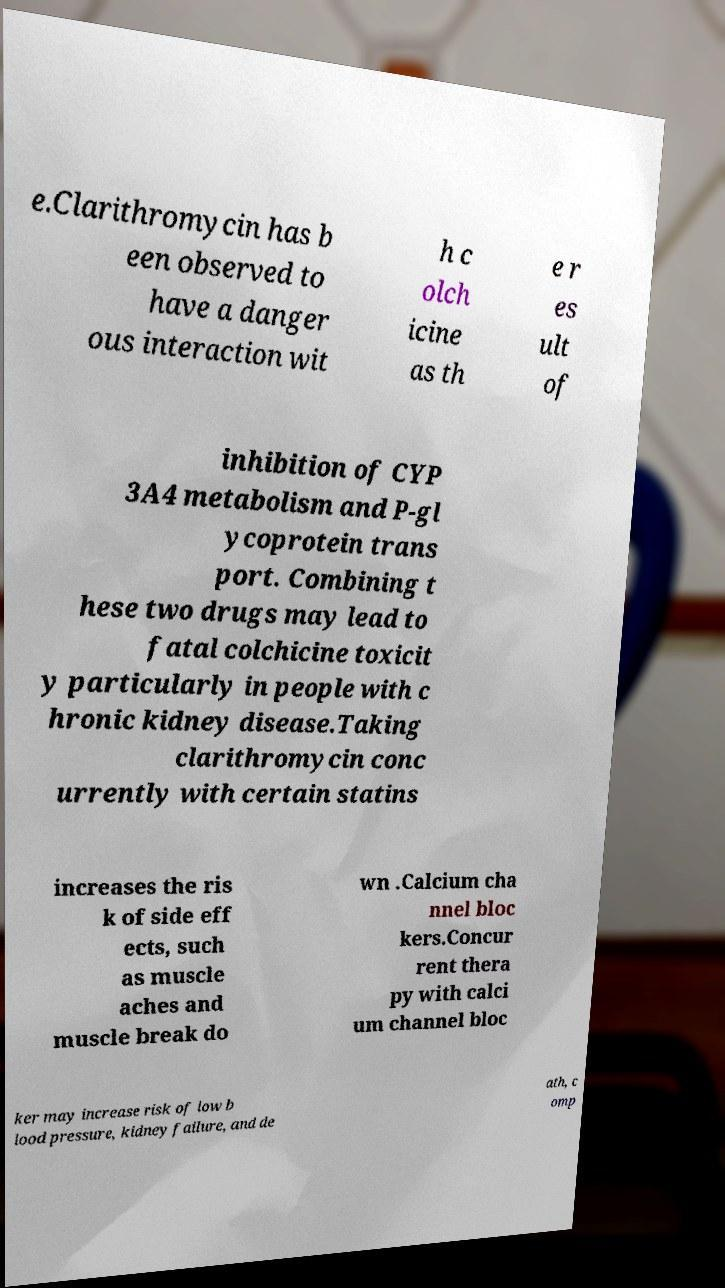Please identify and transcribe the text found in this image. e.Clarithromycin has b een observed to have a danger ous interaction wit h c olch icine as th e r es ult of inhibition of CYP 3A4 metabolism and P-gl ycoprotein trans port. Combining t hese two drugs may lead to fatal colchicine toxicit y particularly in people with c hronic kidney disease.Taking clarithromycin conc urrently with certain statins increases the ris k of side eff ects, such as muscle aches and muscle break do wn .Calcium cha nnel bloc kers.Concur rent thera py with calci um channel bloc ker may increase risk of low b lood pressure, kidney failure, and de ath, c omp 